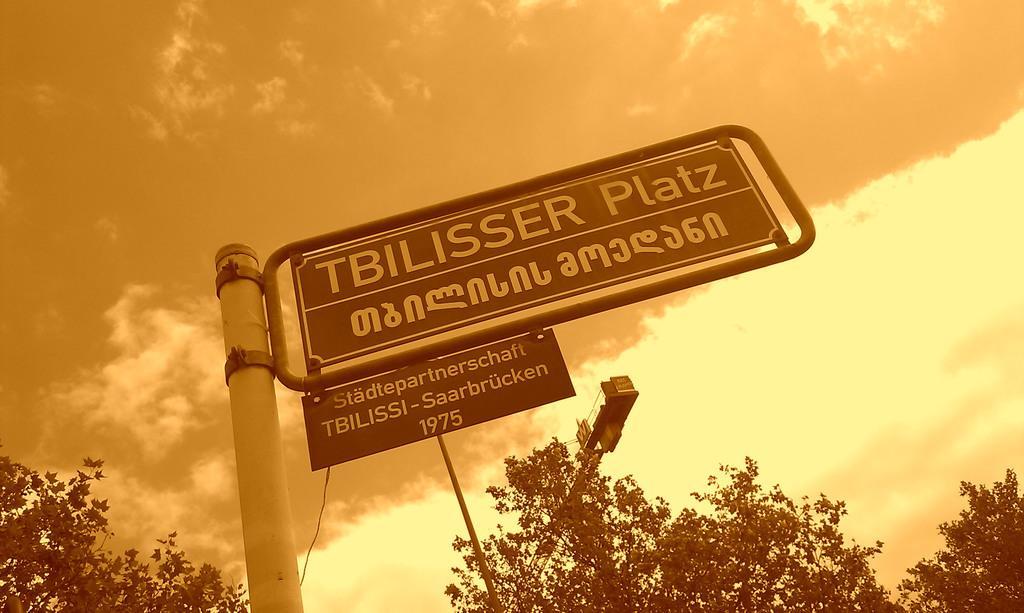Describe this image in one or two sentences. In this image there is a board with some text, a crane, a rope, there are few trees and some clouds in the sky. 